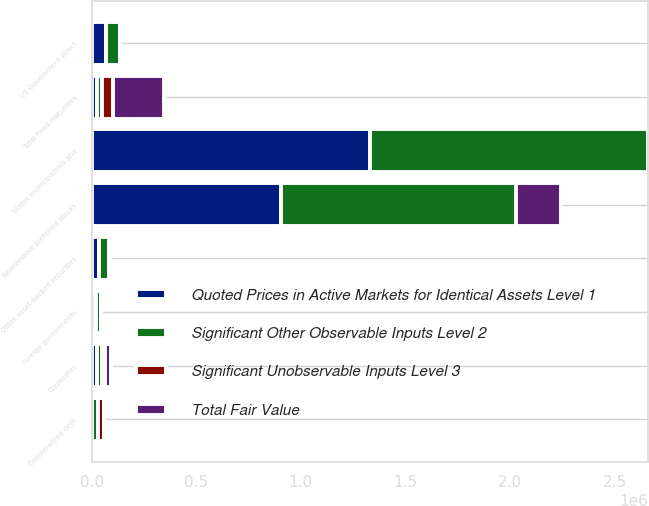Convert chart to OTSL. <chart><loc_0><loc_0><loc_500><loc_500><stacked_bar_chart><ecel><fcel>US Government direct<fcel>States municipalities and<fcel>Foreign governments<fcel>Corporates<fcel>Collateralized debt<fcel>Other asset-backed securities<fcel>Redeemable preferred stocks<fcel>Total fixed maturities<nl><fcel>Total Fair Value<fcel>0<fcel>0<fcel>0<fcel>28092<fcel>0<fcel>0<fcel>217613<fcel>245705<nl><fcel>Quoted Prices in Active Markets for Identical Assets Level 1<fcel>67035<fcel>1.32982e+06<fcel>23159<fcel>25625.5<fcel>0<fcel>37558<fcel>904656<fcel>25625.5<nl><fcel>Significant Unobservable Inputs Level 3<fcel>0<fcel>0<fcel>0<fcel>11250<fcel>30320<fcel>7122<fcel>0<fcel>48692<nl><fcel>Significant Other Observable Inputs Level 2<fcel>67035<fcel>1.32982e+06<fcel>23159<fcel>25625.5<fcel>30320<fcel>44680<fcel>1.12227e+06<fcel>25625.5<nl></chart> 